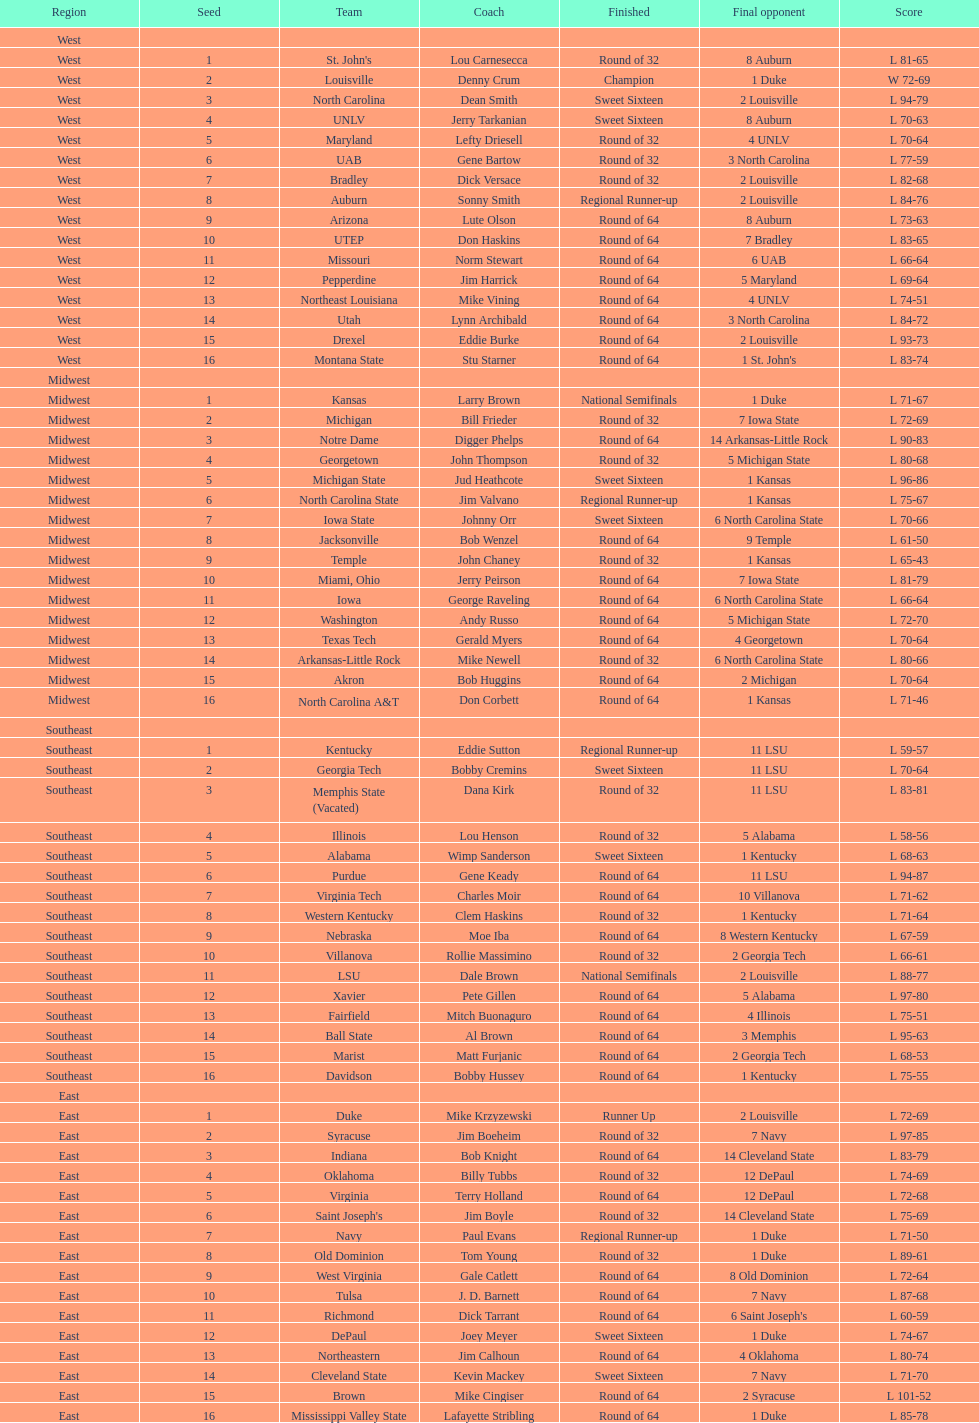I'm looking to parse the entire table for insights. Could you assist me with that? {'header': ['Region', 'Seed', 'Team', 'Coach', 'Finished', 'Final opponent', 'Score'], 'rows': [['West', '', '', '', '', '', ''], ['West', '1', "St. John's", 'Lou Carnesecca', 'Round of 32', '8 Auburn', 'L 81-65'], ['West', '2', 'Louisville', 'Denny Crum', 'Champion', '1 Duke', 'W 72-69'], ['West', '3', 'North Carolina', 'Dean Smith', 'Sweet Sixteen', '2 Louisville', 'L 94-79'], ['West', '4', 'UNLV', 'Jerry Tarkanian', 'Sweet Sixteen', '8 Auburn', 'L 70-63'], ['West', '5', 'Maryland', 'Lefty Driesell', 'Round of 32', '4 UNLV', 'L 70-64'], ['West', '6', 'UAB', 'Gene Bartow', 'Round of 32', '3 North Carolina', 'L 77-59'], ['West', '7', 'Bradley', 'Dick Versace', 'Round of 32', '2 Louisville', 'L 82-68'], ['West', '8', 'Auburn', 'Sonny Smith', 'Regional Runner-up', '2 Louisville', 'L 84-76'], ['West', '9', 'Arizona', 'Lute Olson', 'Round of 64', '8 Auburn', 'L 73-63'], ['West', '10', 'UTEP', 'Don Haskins', 'Round of 64', '7 Bradley', 'L 83-65'], ['West', '11', 'Missouri', 'Norm Stewart', 'Round of 64', '6 UAB', 'L 66-64'], ['West', '12', 'Pepperdine', 'Jim Harrick', 'Round of 64', '5 Maryland', 'L 69-64'], ['West', '13', 'Northeast Louisiana', 'Mike Vining', 'Round of 64', '4 UNLV', 'L 74-51'], ['West', '14', 'Utah', 'Lynn Archibald', 'Round of 64', '3 North Carolina', 'L 84-72'], ['West', '15', 'Drexel', 'Eddie Burke', 'Round of 64', '2 Louisville', 'L 93-73'], ['West', '16', 'Montana State', 'Stu Starner', 'Round of 64', "1 St. John's", 'L 83-74'], ['Midwest', '', '', '', '', '', ''], ['Midwest', '1', 'Kansas', 'Larry Brown', 'National Semifinals', '1 Duke', 'L 71-67'], ['Midwest', '2', 'Michigan', 'Bill Frieder', 'Round of 32', '7 Iowa State', 'L 72-69'], ['Midwest', '3', 'Notre Dame', 'Digger Phelps', 'Round of 64', '14 Arkansas-Little Rock', 'L 90-83'], ['Midwest', '4', 'Georgetown', 'John Thompson', 'Round of 32', '5 Michigan State', 'L 80-68'], ['Midwest', '5', 'Michigan State', 'Jud Heathcote', 'Sweet Sixteen', '1 Kansas', 'L 96-86'], ['Midwest', '6', 'North Carolina State', 'Jim Valvano', 'Regional Runner-up', '1 Kansas', 'L 75-67'], ['Midwest', '7', 'Iowa State', 'Johnny Orr', 'Sweet Sixteen', '6 North Carolina State', 'L 70-66'], ['Midwest', '8', 'Jacksonville', 'Bob Wenzel', 'Round of 64', '9 Temple', 'L 61-50'], ['Midwest', '9', 'Temple', 'John Chaney', 'Round of 32', '1 Kansas', 'L 65-43'], ['Midwest', '10', 'Miami, Ohio', 'Jerry Peirson', 'Round of 64', '7 Iowa State', 'L 81-79'], ['Midwest', '11', 'Iowa', 'George Raveling', 'Round of 64', '6 North Carolina State', 'L 66-64'], ['Midwest', '12', 'Washington', 'Andy Russo', 'Round of 64', '5 Michigan State', 'L 72-70'], ['Midwest', '13', 'Texas Tech', 'Gerald Myers', 'Round of 64', '4 Georgetown', 'L 70-64'], ['Midwest', '14', 'Arkansas-Little Rock', 'Mike Newell', 'Round of 32', '6 North Carolina State', 'L 80-66'], ['Midwest', '15', 'Akron', 'Bob Huggins', 'Round of 64', '2 Michigan', 'L 70-64'], ['Midwest', '16', 'North Carolina A&T', 'Don Corbett', 'Round of 64', '1 Kansas', 'L 71-46'], ['Southeast', '', '', '', '', '', ''], ['Southeast', '1', 'Kentucky', 'Eddie Sutton', 'Regional Runner-up', '11 LSU', 'L 59-57'], ['Southeast', '2', 'Georgia Tech', 'Bobby Cremins', 'Sweet Sixteen', '11 LSU', 'L 70-64'], ['Southeast', '3', 'Memphis State (Vacated)', 'Dana Kirk', 'Round of 32', '11 LSU', 'L 83-81'], ['Southeast', '4', 'Illinois', 'Lou Henson', 'Round of 32', '5 Alabama', 'L 58-56'], ['Southeast', '5', 'Alabama', 'Wimp Sanderson', 'Sweet Sixteen', '1 Kentucky', 'L 68-63'], ['Southeast', '6', 'Purdue', 'Gene Keady', 'Round of 64', '11 LSU', 'L 94-87'], ['Southeast', '7', 'Virginia Tech', 'Charles Moir', 'Round of 64', '10 Villanova', 'L 71-62'], ['Southeast', '8', 'Western Kentucky', 'Clem Haskins', 'Round of 32', '1 Kentucky', 'L 71-64'], ['Southeast', '9', 'Nebraska', 'Moe Iba', 'Round of 64', '8 Western Kentucky', 'L 67-59'], ['Southeast', '10', 'Villanova', 'Rollie Massimino', 'Round of 32', '2 Georgia Tech', 'L 66-61'], ['Southeast', '11', 'LSU', 'Dale Brown', 'National Semifinals', '2 Louisville', 'L 88-77'], ['Southeast', '12', 'Xavier', 'Pete Gillen', 'Round of 64', '5 Alabama', 'L 97-80'], ['Southeast', '13', 'Fairfield', 'Mitch Buonaguro', 'Round of 64', '4 Illinois', 'L 75-51'], ['Southeast', '14', 'Ball State', 'Al Brown', 'Round of 64', '3 Memphis', 'L 95-63'], ['Southeast', '15', 'Marist', 'Matt Furjanic', 'Round of 64', '2 Georgia Tech', 'L 68-53'], ['Southeast', '16', 'Davidson', 'Bobby Hussey', 'Round of 64', '1 Kentucky', 'L 75-55'], ['East', '', '', '', '', '', ''], ['East', '1', 'Duke', 'Mike Krzyzewski', 'Runner Up', '2 Louisville', 'L 72-69'], ['East', '2', 'Syracuse', 'Jim Boeheim', 'Round of 32', '7 Navy', 'L 97-85'], ['East', '3', 'Indiana', 'Bob Knight', 'Round of 64', '14 Cleveland State', 'L 83-79'], ['East', '4', 'Oklahoma', 'Billy Tubbs', 'Round of 32', '12 DePaul', 'L 74-69'], ['East', '5', 'Virginia', 'Terry Holland', 'Round of 64', '12 DePaul', 'L 72-68'], ['East', '6', "Saint Joseph's", 'Jim Boyle', 'Round of 32', '14 Cleveland State', 'L 75-69'], ['East', '7', 'Navy', 'Paul Evans', 'Regional Runner-up', '1 Duke', 'L 71-50'], ['East', '8', 'Old Dominion', 'Tom Young', 'Round of 32', '1 Duke', 'L 89-61'], ['East', '9', 'West Virginia', 'Gale Catlett', 'Round of 64', '8 Old Dominion', 'L 72-64'], ['East', '10', 'Tulsa', 'J. D. Barnett', 'Round of 64', '7 Navy', 'L 87-68'], ['East', '11', 'Richmond', 'Dick Tarrant', 'Round of 64', "6 Saint Joseph's", 'L 60-59'], ['East', '12', 'DePaul', 'Joey Meyer', 'Sweet Sixteen', '1 Duke', 'L 74-67'], ['East', '13', 'Northeastern', 'Jim Calhoun', 'Round of 64', '4 Oklahoma', 'L 80-74'], ['East', '14', 'Cleveland State', 'Kevin Mackey', 'Sweet Sixteen', '7 Navy', 'L 71-70'], ['East', '15', 'Brown', 'Mike Cingiser', 'Round of 64', '2 Syracuse', 'L 101-52'], ['East', '16', 'Mississippi Valley State', 'Lafayette Stribling', 'Round of 64', '1 Duke', 'L 85-78']]} In the tournament, did st. john's or north carolina a&t make it further before being eliminated? North Carolina A&T. 